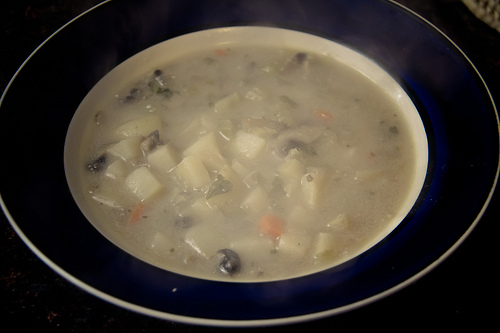<image>
Can you confirm if the soup is under the potato? No. The soup is not positioned under the potato. The vertical relationship between these objects is different. 